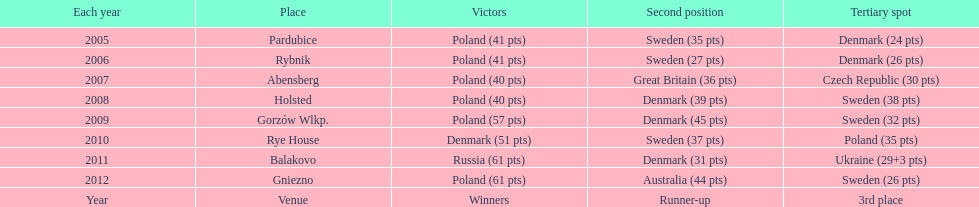What is the total number of points earned in the years 2009? 134. 